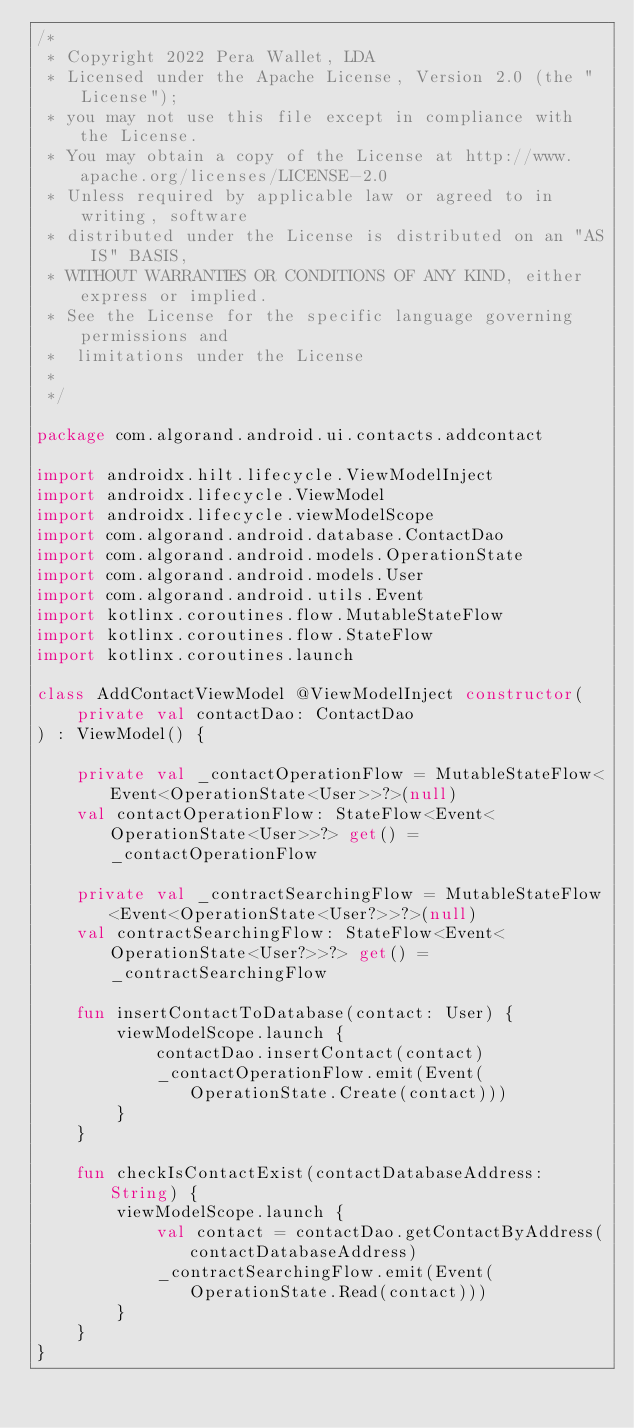<code> <loc_0><loc_0><loc_500><loc_500><_Kotlin_>/*
 * Copyright 2022 Pera Wallet, LDA
 * Licensed under the Apache License, Version 2.0 (the "License");
 * you may not use this file except in compliance with the License.
 * You may obtain a copy of the License at http://www.apache.org/licenses/LICENSE-2.0
 * Unless required by applicable law or agreed to in writing, software
 * distributed under the License is distributed on an "AS IS" BASIS,
 * WITHOUT WARRANTIES OR CONDITIONS OF ANY KIND, either express or implied.
 * See the License for the specific language governing permissions and
 *  limitations under the License
 *
 */

package com.algorand.android.ui.contacts.addcontact

import androidx.hilt.lifecycle.ViewModelInject
import androidx.lifecycle.ViewModel
import androidx.lifecycle.viewModelScope
import com.algorand.android.database.ContactDao
import com.algorand.android.models.OperationState
import com.algorand.android.models.User
import com.algorand.android.utils.Event
import kotlinx.coroutines.flow.MutableStateFlow
import kotlinx.coroutines.flow.StateFlow
import kotlinx.coroutines.launch

class AddContactViewModel @ViewModelInject constructor(
    private val contactDao: ContactDao
) : ViewModel() {

    private val _contactOperationFlow = MutableStateFlow<Event<OperationState<User>>?>(null)
    val contactOperationFlow: StateFlow<Event<OperationState<User>>?> get() = _contactOperationFlow

    private val _contractSearchingFlow = MutableStateFlow<Event<OperationState<User?>>?>(null)
    val contractSearchingFlow: StateFlow<Event<OperationState<User?>>?> get() = _contractSearchingFlow

    fun insertContactToDatabase(contact: User) {
        viewModelScope.launch {
            contactDao.insertContact(contact)
            _contactOperationFlow.emit(Event(OperationState.Create(contact)))
        }
    }

    fun checkIsContactExist(contactDatabaseAddress: String) {
        viewModelScope.launch {
            val contact = contactDao.getContactByAddress(contactDatabaseAddress)
            _contractSearchingFlow.emit(Event(OperationState.Read(contact)))
        }
    }
}
</code> 